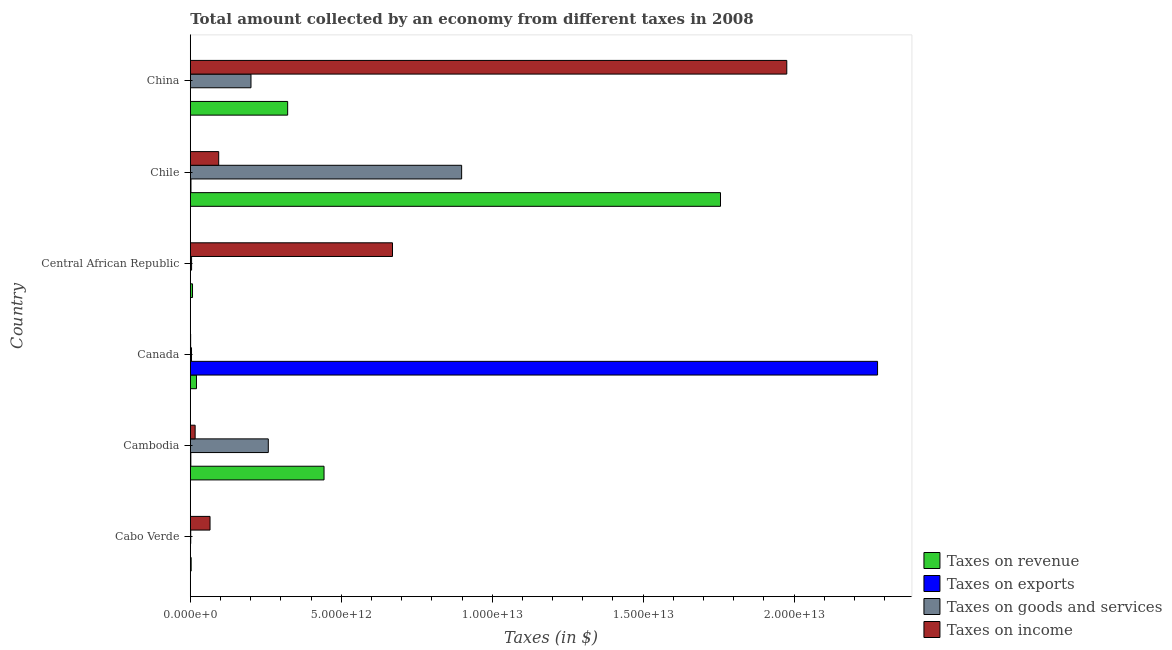How many bars are there on the 2nd tick from the top?
Ensure brevity in your answer.  4. What is the label of the 1st group of bars from the top?
Your response must be concise. China. What is the amount collected as tax on goods in Cambodia?
Your answer should be compact. 2.58e+12. Across all countries, what is the maximum amount collected as tax on income?
Your answer should be compact. 1.98e+13. Across all countries, what is the minimum amount collected as tax on income?
Give a very brief answer. 1.14e+1. In which country was the amount collected as tax on goods minimum?
Provide a succinct answer. Cabo Verde. What is the total amount collected as tax on goods in the graph?
Offer a very short reply. 1.37e+13. What is the difference between the amount collected as tax on exports in Chile and that in China?
Offer a very short reply. 2.21e+1. What is the difference between the amount collected as tax on exports in Central African Republic and the amount collected as tax on revenue in Chile?
Your answer should be very brief. -1.76e+13. What is the average amount collected as tax on income per country?
Your answer should be compact. 4.70e+12. What is the difference between the amount collected as tax on exports and amount collected as tax on revenue in Cambodia?
Ensure brevity in your answer.  -4.41e+12. What is the ratio of the amount collected as tax on exports in Canada to that in Chile?
Your response must be concise. 1022.38. Is the amount collected as tax on goods in Cambodia less than that in Central African Republic?
Your response must be concise. No. What is the difference between the highest and the second highest amount collected as tax on goods?
Give a very brief answer. 6.40e+12. What is the difference between the highest and the lowest amount collected as tax on income?
Make the answer very short. 1.97e+13. Is it the case that in every country, the sum of the amount collected as tax on goods and amount collected as tax on exports is greater than the sum of amount collected as tax on income and amount collected as tax on revenue?
Provide a succinct answer. No. What does the 3rd bar from the top in Chile represents?
Keep it short and to the point. Taxes on exports. What does the 1st bar from the bottom in Cabo Verde represents?
Provide a short and direct response. Taxes on revenue. Is it the case that in every country, the sum of the amount collected as tax on revenue and amount collected as tax on exports is greater than the amount collected as tax on goods?
Your answer should be compact. Yes. How many bars are there?
Offer a very short reply. 24. Are all the bars in the graph horizontal?
Give a very brief answer. Yes. What is the difference between two consecutive major ticks on the X-axis?
Offer a very short reply. 5.00e+12. Are the values on the major ticks of X-axis written in scientific E-notation?
Give a very brief answer. Yes. What is the title of the graph?
Provide a succinct answer. Total amount collected by an economy from different taxes in 2008. Does "International Development Association" appear as one of the legend labels in the graph?
Provide a succinct answer. No. What is the label or title of the X-axis?
Give a very brief answer. Taxes (in $). What is the Taxes (in $) in Taxes on revenue in Cabo Verde?
Your answer should be very brief. 2.87e+1. What is the Taxes (in $) of Taxes on exports in Cabo Verde?
Offer a terse response. 6.26e+06. What is the Taxes (in $) of Taxes on goods and services in Cabo Verde?
Provide a succinct answer. 1.44e+1. What is the Taxes (in $) of Taxes on income in Cabo Verde?
Provide a succinct answer. 6.54e+11. What is the Taxes (in $) in Taxes on revenue in Cambodia?
Provide a short and direct response. 4.43e+12. What is the Taxes (in $) in Taxes on exports in Cambodia?
Give a very brief answer. 1.78e+1. What is the Taxes (in $) of Taxes on goods and services in Cambodia?
Ensure brevity in your answer.  2.58e+12. What is the Taxes (in $) in Taxes on income in Cambodia?
Provide a succinct answer. 1.60e+11. What is the Taxes (in $) of Taxes on revenue in Canada?
Provide a short and direct response. 2.05e+11. What is the Taxes (in $) in Taxes on exports in Canada?
Make the answer very short. 2.28e+13. What is the Taxes (in $) in Taxes on goods and services in Canada?
Offer a very short reply. 4.05e+1. What is the Taxes (in $) in Taxes on income in Canada?
Provide a succinct answer. 1.14e+1. What is the Taxes (in $) of Taxes on revenue in Central African Republic?
Provide a short and direct response. 7.37e+1. What is the Taxes (in $) in Taxes on exports in Central African Republic?
Keep it short and to the point. 1.81e+06. What is the Taxes (in $) of Taxes on goods and services in Central African Republic?
Ensure brevity in your answer.  4.23e+1. What is the Taxes (in $) in Taxes on income in Central African Republic?
Make the answer very short. 6.70e+12. What is the Taxes (in $) in Taxes on revenue in Chile?
Ensure brevity in your answer.  1.76e+13. What is the Taxes (in $) of Taxes on exports in Chile?
Your answer should be very brief. 2.23e+1. What is the Taxes (in $) of Taxes on goods and services in Chile?
Provide a succinct answer. 8.99e+12. What is the Taxes (in $) in Taxes on income in Chile?
Offer a very short reply. 9.41e+11. What is the Taxes (in $) of Taxes on revenue in China?
Give a very brief answer. 3.22e+12. What is the Taxes (in $) in Taxes on exports in China?
Ensure brevity in your answer.  1.39e+08. What is the Taxes (in $) of Taxes on goods and services in China?
Keep it short and to the point. 2.01e+12. What is the Taxes (in $) of Taxes on income in China?
Provide a short and direct response. 1.98e+13. Across all countries, what is the maximum Taxes (in $) of Taxes on revenue?
Your answer should be very brief. 1.76e+13. Across all countries, what is the maximum Taxes (in $) in Taxes on exports?
Provide a short and direct response. 2.28e+13. Across all countries, what is the maximum Taxes (in $) in Taxes on goods and services?
Provide a short and direct response. 8.99e+12. Across all countries, what is the maximum Taxes (in $) of Taxes on income?
Keep it short and to the point. 1.98e+13. Across all countries, what is the minimum Taxes (in $) in Taxes on revenue?
Your response must be concise. 2.87e+1. Across all countries, what is the minimum Taxes (in $) of Taxes on exports?
Offer a very short reply. 1.81e+06. Across all countries, what is the minimum Taxes (in $) of Taxes on goods and services?
Ensure brevity in your answer.  1.44e+1. Across all countries, what is the minimum Taxes (in $) in Taxes on income?
Provide a succinct answer. 1.14e+1. What is the total Taxes (in $) in Taxes on revenue in the graph?
Offer a very short reply. 2.55e+13. What is the total Taxes (in $) in Taxes on exports in the graph?
Ensure brevity in your answer.  2.28e+13. What is the total Taxes (in $) of Taxes on goods and services in the graph?
Give a very brief answer. 1.37e+13. What is the total Taxes (in $) in Taxes on income in the graph?
Provide a short and direct response. 2.82e+13. What is the difference between the Taxes (in $) of Taxes on revenue in Cabo Verde and that in Cambodia?
Keep it short and to the point. -4.40e+12. What is the difference between the Taxes (in $) in Taxes on exports in Cabo Verde and that in Cambodia?
Keep it short and to the point. -1.78e+1. What is the difference between the Taxes (in $) in Taxes on goods and services in Cabo Verde and that in Cambodia?
Offer a very short reply. -2.57e+12. What is the difference between the Taxes (in $) in Taxes on income in Cabo Verde and that in Cambodia?
Your answer should be very brief. 4.93e+11. What is the difference between the Taxes (in $) of Taxes on revenue in Cabo Verde and that in Canada?
Your answer should be compact. -1.76e+11. What is the difference between the Taxes (in $) in Taxes on exports in Cabo Verde and that in Canada?
Your response must be concise. -2.28e+13. What is the difference between the Taxes (in $) of Taxes on goods and services in Cabo Verde and that in Canada?
Give a very brief answer. -2.61e+1. What is the difference between the Taxes (in $) of Taxes on income in Cabo Verde and that in Canada?
Provide a short and direct response. 6.43e+11. What is the difference between the Taxes (in $) in Taxes on revenue in Cabo Verde and that in Central African Republic?
Provide a short and direct response. -4.50e+1. What is the difference between the Taxes (in $) of Taxes on exports in Cabo Verde and that in Central African Republic?
Give a very brief answer. 4.45e+06. What is the difference between the Taxes (in $) of Taxes on goods and services in Cabo Verde and that in Central African Republic?
Keep it short and to the point. -2.79e+1. What is the difference between the Taxes (in $) of Taxes on income in Cabo Verde and that in Central African Republic?
Offer a terse response. -6.04e+12. What is the difference between the Taxes (in $) of Taxes on revenue in Cabo Verde and that in Chile?
Your answer should be compact. -1.75e+13. What is the difference between the Taxes (in $) in Taxes on exports in Cabo Verde and that in Chile?
Ensure brevity in your answer.  -2.23e+1. What is the difference between the Taxes (in $) of Taxes on goods and services in Cabo Verde and that in Chile?
Offer a very short reply. -8.97e+12. What is the difference between the Taxes (in $) of Taxes on income in Cabo Verde and that in Chile?
Provide a succinct answer. -2.87e+11. What is the difference between the Taxes (in $) in Taxes on revenue in Cabo Verde and that in China?
Your response must be concise. -3.20e+12. What is the difference between the Taxes (in $) in Taxes on exports in Cabo Verde and that in China?
Provide a short and direct response. -1.33e+08. What is the difference between the Taxes (in $) of Taxes on goods and services in Cabo Verde and that in China?
Provide a succinct answer. -2.00e+12. What is the difference between the Taxes (in $) of Taxes on income in Cabo Verde and that in China?
Your response must be concise. -1.91e+13. What is the difference between the Taxes (in $) in Taxes on revenue in Cambodia and that in Canada?
Your response must be concise. 4.22e+12. What is the difference between the Taxes (in $) in Taxes on exports in Cambodia and that in Canada?
Ensure brevity in your answer.  -2.27e+13. What is the difference between the Taxes (in $) of Taxes on goods and services in Cambodia and that in Canada?
Your answer should be very brief. 2.54e+12. What is the difference between the Taxes (in $) in Taxes on income in Cambodia and that in Canada?
Keep it short and to the point. 1.49e+11. What is the difference between the Taxes (in $) of Taxes on revenue in Cambodia and that in Central African Republic?
Offer a terse response. 4.36e+12. What is the difference between the Taxes (in $) in Taxes on exports in Cambodia and that in Central African Republic?
Keep it short and to the point. 1.78e+1. What is the difference between the Taxes (in $) in Taxes on goods and services in Cambodia and that in Central African Republic?
Your answer should be very brief. 2.54e+12. What is the difference between the Taxes (in $) of Taxes on income in Cambodia and that in Central African Republic?
Give a very brief answer. -6.54e+12. What is the difference between the Taxes (in $) in Taxes on revenue in Cambodia and that in Chile?
Your answer should be very brief. -1.31e+13. What is the difference between the Taxes (in $) of Taxes on exports in Cambodia and that in Chile?
Offer a very short reply. -4.48e+09. What is the difference between the Taxes (in $) in Taxes on goods and services in Cambodia and that in Chile?
Your answer should be very brief. -6.40e+12. What is the difference between the Taxes (in $) of Taxes on income in Cambodia and that in Chile?
Your answer should be compact. -7.80e+11. What is the difference between the Taxes (in $) in Taxes on revenue in Cambodia and that in China?
Make the answer very short. 1.21e+12. What is the difference between the Taxes (in $) in Taxes on exports in Cambodia and that in China?
Keep it short and to the point. 1.77e+1. What is the difference between the Taxes (in $) of Taxes on goods and services in Cambodia and that in China?
Provide a succinct answer. 5.73e+11. What is the difference between the Taxes (in $) in Taxes on income in Cambodia and that in China?
Offer a very short reply. -1.96e+13. What is the difference between the Taxes (in $) in Taxes on revenue in Canada and that in Central African Republic?
Make the answer very short. 1.31e+11. What is the difference between the Taxes (in $) in Taxes on exports in Canada and that in Central African Republic?
Offer a terse response. 2.28e+13. What is the difference between the Taxes (in $) in Taxes on goods and services in Canada and that in Central African Republic?
Make the answer very short. -1.82e+09. What is the difference between the Taxes (in $) of Taxes on income in Canada and that in Central African Republic?
Provide a short and direct response. -6.69e+12. What is the difference between the Taxes (in $) in Taxes on revenue in Canada and that in Chile?
Give a very brief answer. -1.74e+13. What is the difference between the Taxes (in $) of Taxes on exports in Canada and that in Chile?
Keep it short and to the point. 2.27e+13. What is the difference between the Taxes (in $) in Taxes on goods and services in Canada and that in Chile?
Make the answer very short. -8.95e+12. What is the difference between the Taxes (in $) in Taxes on income in Canada and that in Chile?
Keep it short and to the point. -9.29e+11. What is the difference between the Taxes (in $) of Taxes on revenue in Canada and that in China?
Keep it short and to the point. -3.02e+12. What is the difference between the Taxes (in $) in Taxes on exports in Canada and that in China?
Provide a succinct answer. 2.28e+13. What is the difference between the Taxes (in $) of Taxes on goods and services in Canada and that in China?
Make the answer very short. -1.97e+12. What is the difference between the Taxes (in $) of Taxes on income in Canada and that in China?
Make the answer very short. -1.97e+13. What is the difference between the Taxes (in $) in Taxes on revenue in Central African Republic and that in Chile?
Your answer should be compact. -1.75e+13. What is the difference between the Taxes (in $) of Taxes on exports in Central African Republic and that in Chile?
Give a very brief answer. -2.23e+1. What is the difference between the Taxes (in $) in Taxes on goods and services in Central African Republic and that in Chile?
Offer a terse response. -8.95e+12. What is the difference between the Taxes (in $) of Taxes on income in Central African Republic and that in Chile?
Ensure brevity in your answer.  5.76e+12. What is the difference between the Taxes (in $) in Taxes on revenue in Central African Republic and that in China?
Offer a very short reply. -3.15e+12. What is the difference between the Taxes (in $) in Taxes on exports in Central African Republic and that in China?
Offer a terse response. -1.37e+08. What is the difference between the Taxes (in $) of Taxes on goods and services in Central African Republic and that in China?
Provide a succinct answer. -1.97e+12. What is the difference between the Taxes (in $) in Taxes on income in Central African Republic and that in China?
Your answer should be very brief. -1.31e+13. What is the difference between the Taxes (in $) in Taxes on revenue in Chile and that in China?
Offer a very short reply. 1.43e+13. What is the difference between the Taxes (in $) of Taxes on exports in Chile and that in China?
Provide a short and direct response. 2.21e+1. What is the difference between the Taxes (in $) of Taxes on goods and services in Chile and that in China?
Your response must be concise. 6.98e+12. What is the difference between the Taxes (in $) in Taxes on income in Chile and that in China?
Offer a terse response. -1.88e+13. What is the difference between the Taxes (in $) of Taxes on revenue in Cabo Verde and the Taxes (in $) of Taxes on exports in Cambodia?
Your response must be concise. 1.09e+1. What is the difference between the Taxes (in $) of Taxes on revenue in Cabo Verde and the Taxes (in $) of Taxes on goods and services in Cambodia?
Make the answer very short. -2.55e+12. What is the difference between the Taxes (in $) in Taxes on revenue in Cabo Verde and the Taxes (in $) in Taxes on income in Cambodia?
Ensure brevity in your answer.  -1.32e+11. What is the difference between the Taxes (in $) of Taxes on exports in Cabo Verde and the Taxes (in $) of Taxes on goods and services in Cambodia?
Your answer should be very brief. -2.58e+12. What is the difference between the Taxes (in $) of Taxes on exports in Cabo Verde and the Taxes (in $) of Taxes on income in Cambodia?
Your answer should be compact. -1.60e+11. What is the difference between the Taxes (in $) of Taxes on goods and services in Cabo Verde and the Taxes (in $) of Taxes on income in Cambodia?
Provide a short and direct response. -1.46e+11. What is the difference between the Taxes (in $) of Taxes on revenue in Cabo Verde and the Taxes (in $) of Taxes on exports in Canada?
Provide a succinct answer. -2.27e+13. What is the difference between the Taxes (in $) of Taxes on revenue in Cabo Verde and the Taxes (in $) of Taxes on goods and services in Canada?
Your answer should be compact. -1.18e+1. What is the difference between the Taxes (in $) in Taxes on revenue in Cabo Verde and the Taxes (in $) in Taxes on income in Canada?
Your answer should be very brief. 1.73e+1. What is the difference between the Taxes (in $) of Taxes on exports in Cabo Verde and the Taxes (in $) of Taxes on goods and services in Canada?
Make the answer very short. -4.05e+1. What is the difference between the Taxes (in $) of Taxes on exports in Cabo Verde and the Taxes (in $) of Taxes on income in Canada?
Make the answer very short. -1.14e+1. What is the difference between the Taxes (in $) of Taxes on goods and services in Cabo Verde and the Taxes (in $) of Taxes on income in Canada?
Offer a terse response. 3.04e+09. What is the difference between the Taxes (in $) in Taxes on revenue in Cabo Verde and the Taxes (in $) in Taxes on exports in Central African Republic?
Offer a terse response. 2.87e+1. What is the difference between the Taxes (in $) in Taxes on revenue in Cabo Verde and the Taxes (in $) in Taxes on goods and services in Central African Republic?
Your response must be concise. -1.36e+1. What is the difference between the Taxes (in $) of Taxes on revenue in Cabo Verde and the Taxes (in $) of Taxes on income in Central African Republic?
Your answer should be very brief. -6.67e+12. What is the difference between the Taxes (in $) of Taxes on exports in Cabo Verde and the Taxes (in $) of Taxes on goods and services in Central African Republic?
Keep it short and to the point. -4.23e+1. What is the difference between the Taxes (in $) in Taxes on exports in Cabo Verde and the Taxes (in $) in Taxes on income in Central African Republic?
Ensure brevity in your answer.  -6.70e+12. What is the difference between the Taxes (in $) in Taxes on goods and services in Cabo Verde and the Taxes (in $) in Taxes on income in Central African Republic?
Make the answer very short. -6.68e+12. What is the difference between the Taxes (in $) of Taxes on revenue in Cabo Verde and the Taxes (in $) of Taxes on exports in Chile?
Offer a very short reply. 6.40e+09. What is the difference between the Taxes (in $) in Taxes on revenue in Cabo Verde and the Taxes (in $) in Taxes on goods and services in Chile?
Provide a short and direct response. -8.96e+12. What is the difference between the Taxes (in $) of Taxes on revenue in Cabo Verde and the Taxes (in $) of Taxes on income in Chile?
Make the answer very short. -9.12e+11. What is the difference between the Taxes (in $) in Taxes on exports in Cabo Verde and the Taxes (in $) in Taxes on goods and services in Chile?
Offer a terse response. -8.99e+12. What is the difference between the Taxes (in $) in Taxes on exports in Cabo Verde and the Taxes (in $) in Taxes on income in Chile?
Provide a succinct answer. -9.41e+11. What is the difference between the Taxes (in $) in Taxes on goods and services in Cabo Verde and the Taxes (in $) in Taxes on income in Chile?
Offer a very short reply. -9.26e+11. What is the difference between the Taxes (in $) of Taxes on revenue in Cabo Verde and the Taxes (in $) of Taxes on exports in China?
Offer a very short reply. 2.85e+1. What is the difference between the Taxes (in $) in Taxes on revenue in Cabo Verde and the Taxes (in $) in Taxes on goods and services in China?
Keep it short and to the point. -1.98e+12. What is the difference between the Taxes (in $) in Taxes on revenue in Cabo Verde and the Taxes (in $) in Taxes on income in China?
Give a very brief answer. -1.97e+13. What is the difference between the Taxes (in $) of Taxes on exports in Cabo Verde and the Taxes (in $) of Taxes on goods and services in China?
Your response must be concise. -2.01e+12. What is the difference between the Taxes (in $) in Taxes on exports in Cabo Verde and the Taxes (in $) in Taxes on income in China?
Your answer should be very brief. -1.98e+13. What is the difference between the Taxes (in $) in Taxes on goods and services in Cabo Verde and the Taxes (in $) in Taxes on income in China?
Ensure brevity in your answer.  -1.97e+13. What is the difference between the Taxes (in $) in Taxes on revenue in Cambodia and the Taxes (in $) in Taxes on exports in Canada?
Offer a very short reply. -1.83e+13. What is the difference between the Taxes (in $) of Taxes on revenue in Cambodia and the Taxes (in $) of Taxes on goods and services in Canada?
Make the answer very short. 4.39e+12. What is the difference between the Taxes (in $) in Taxes on revenue in Cambodia and the Taxes (in $) in Taxes on income in Canada?
Make the answer very short. 4.42e+12. What is the difference between the Taxes (in $) in Taxes on exports in Cambodia and the Taxes (in $) in Taxes on goods and services in Canada?
Give a very brief answer. -2.27e+1. What is the difference between the Taxes (in $) of Taxes on exports in Cambodia and the Taxes (in $) of Taxes on income in Canada?
Offer a very short reply. 6.43e+09. What is the difference between the Taxes (in $) of Taxes on goods and services in Cambodia and the Taxes (in $) of Taxes on income in Canada?
Provide a succinct answer. 2.57e+12. What is the difference between the Taxes (in $) of Taxes on revenue in Cambodia and the Taxes (in $) of Taxes on exports in Central African Republic?
Make the answer very short. 4.43e+12. What is the difference between the Taxes (in $) of Taxes on revenue in Cambodia and the Taxes (in $) of Taxes on goods and services in Central African Republic?
Your response must be concise. 4.39e+12. What is the difference between the Taxes (in $) in Taxes on revenue in Cambodia and the Taxes (in $) in Taxes on income in Central African Republic?
Offer a terse response. -2.27e+12. What is the difference between the Taxes (in $) in Taxes on exports in Cambodia and the Taxes (in $) in Taxes on goods and services in Central African Republic?
Ensure brevity in your answer.  -2.45e+1. What is the difference between the Taxes (in $) in Taxes on exports in Cambodia and the Taxes (in $) in Taxes on income in Central African Republic?
Offer a terse response. -6.68e+12. What is the difference between the Taxes (in $) in Taxes on goods and services in Cambodia and the Taxes (in $) in Taxes on income in Central African Republic?
Give a very brief answer. -4.11e+12. What is the difference between the Taxes (in $) of Taxes on revenue in Cambodia and the Taxes (in $) of Taxes on exports in Chile?
Offer a terse response. 4.41e+12. What is the difference between the Taxes (in $) of Taxes on revenue in Cambodia and the Taxes (in $) of Taxes on goods and services in Chile?
Your answer should be compact. -4.56e+12. What is the difference between the Taxes (in $) in Taxes on revenue in Cambodia and the Taxes (in $) in Taxes on income in Chile?
Your response must be concise. 3.49e+12. What is the difference between the Taxes (in $) of Taxes on exports in Cambodia and the Taxes (in $) of Taxes on goods and services in Chile?
Give a very brief answer. -8.97e+12. What is the difference between the Taxes (in $) in Taxes on exports in Cambodia and the Taxes (in $) in Taxes on income in Chile?
Your response must be concise. -9.23e+11. What is the difference between the Taxes (in $) in Taxes on goods and services in Cambodia and the Taxes (in $) in Taxes on income in Chile?
Provide a succinct answer. 1.64e+12. What is the difference between the Taxes (in $) of Taxes on revenue in Cambodia and the Taxes (in $) of Taxes on exports in China?
Make the answer very short. 4.43e+12. What is the difference between the Taxes (in $) in Taxes on revenue in Cambodia and the Taxes (in $) in Taxes on goods and services in China?
Keep it short and to the point. 2.42e+12. What is the difference between the Taxes (in $) of Taxes on revenue in Cambodia and the Taxes (in $) of Taxes on income in China?
Offer a terse response. -1.53e+13. What is the difference between the Taxes (in $) in Taxes on exports in Cambodia and the Taxes (in $) in Taxes on goods and services in China?
Your answer should be compact. -1.99e+12. What is the difference between the Taxes (in $) in Taxes on exports in Cambodia and the Taxes (in $) in Taxes on income in China?
Provide a short and direct response. -1.97e+13. What is the difference between the Taxes (in $) in Taxes on goods and services in Cambodia and the Taxes (in $) in Taxes on income in China?
Give a very brief answer. -1.72e+13. What is the difference between the Taxes (in $) of Taxes on revenue in Canada and the Taxes (in $) of Taxes on exports in Central African Republic?
Offer a very short reply. 2.05e+11. What is the difference between the Taxes (in $) of Taxes on revenue in Canada and the Taxes (in $) of Taxes on goods and services in Central African Republic?
Provide a short and direct response. 1.63e+11. What is the difference between the Taxes (in $) of Taxes on revenue in Canada and the Taxes (in $) of Taxes on income in Central African Republic?
Give a very brief answer. -6.49e+12. What is the difference between the Taxes (in $) of Taxes on exports in Canada and the Taxes (in $) of Taxes on goods and services in Central African Republic?
Make the answer very short. 2.27e+13. What is the difference between the Taxes (in $) of Taxes on exports in Canada and the Taxes (in $) of Taxes on income in Central African Republic?
Your response must be concise. 1.61e+13. What is the difference between the Taxes (in $) in Taxes on goods and services in Canada and the Taxes (in $) in Taxes on income in Central African Republic?
Offer a very short reply. -6.66e+12. What is the difference between the Taxes (in $) of Taxes on revenue in Canada and the Taxes (in $) of Taxes on exports in Chile?
Provide a succinct answer. 1.83e+11. What is the difference between the Taxes (in $) in Taxes on revenue in Canada and the Taxes (in $) in Taxes on goods and services in Chile?
Your answer should be compact. -8.78e+12. What is the difference between the Taxes (in $) in Taxes on revenue in Canada and the Taxes (in $) in Taxes on income in Chile?
Offer a very short reply. -7.36e+11. What is the difference between the Taxes (in $) of Taxes on exports in Canada and the Taxes (in $) of Taxes on goods and services in Chile?
Give a very brief answer. 1.38e+13. What is the difference between the Taxes (in $) of Taxes on exports in Canada and the Taxes (in $) of Taxes on income in Chile?
Provide a short and direct response. 2.18e+13. What is the difference between the Taxes (in $) of Taxes on goods and services in Canada and the Taxes (in $) of Taxes on income in Chile?
Keep it short and to the point. -9.00e+11. What is the difference between the Taxes (in $) of Taxes on revenue in Canada and the Taxes (in $) of Taxes on exports in China?
Your answer should be very brief. 2.05e+11. What is the difference between the Taxes (in $) of Taxes on revenue in Canada and the Taxes (in $) of Taxes on goods and services in China?
Your response must be concise. -1.81e+12. What is the difference between the Taxes (in $) of Taxes on revenue in Canada and the Taxes (in $) of Taxes on income in China?
Ensure brevity in your answer.  -1.96e+13. What is the difference between the Taxes (in $) in Taxes on exports in Canada and the Taxes (in $) in Taxes on goods and services in China?
Give a very brief answer. 2.08e+13. What is the difference between the Taxes (in $) in Taxes on exports in Canada and the Taxes (in $) in Taxes on income in China?
Provide a succinct answer. 3.01e+12. What is the difference between the Taxes (in $) of Taxes on goods and services in Canada and the Taxes (in $) of Taxes on income in China?
Ensure brevity in your answer.  -1.97e+13. What is the difference between the Taxes (in $) in Taxes on revenue in Central African Republic and the Taxes (in $) in Taxes on exports in Chile?
Make the answer very short. 5.14e+1. What is the difference between the Taxes (in $) in Taxes on revenue in Central African Republic and the Taxes (in $) in Taxes on goods and services in Chile?
Keep it short and to the point. -8.91e+12. What is the difference between the Taxes (in $) in Taxes on revenue in Central African Republic and the Taxes (in $) in Taxes on income in Chile?
Ensure brevity in your answer.  -8.67e+11. What is the difference between the Taxes (in $) of Taxes on exports in Central African Republic and the Taxes (in $) of Taxes on goods and services in Chile?
Your answer should be compact. -8.99e+12. What is the difference between the Taxes (in $) in Taxes on exports in Central African Republic and the Taxes (in $) in Taxes on income in Chile?
Make the answer very short. -9.41e+11. What is the difference between the Taxes (in $) in Taxes on goods and services in Central African Republic and the Taxes (in $) in Taxes on income in Chile?
Provide a succinct answer. -8.98e+11. What is the difference between the Taxes (in $) of Taxes on revenue in Central African Republic and the Taxes (in $) of Taxes on exports in China?
Ensure brevity in your answer.  7.35e+1. What is the difference between the Taxes (in $) of Taxes on revenue in Central African Republic and the Taxes (in $) of Taxes on goods and services in China?
Ensure brevity in your answer.  -1.94e+12. What is the difference between the Taxes (in $) of Taxes on revenue in Central African Republic and the Taxes (in $) of Taxes on income in China?
Offer a very short reply. -1.97e+13. What is the difference between the Taxes (in $) of Taxes on exports in Central African Republic and the Taxes (in $) of Taxes on goods and services in China?
Provide a succinct answer. -2.01e+12. What is the difference between the Taxes (in $) in Taxes on exports in Central African Republic and the Taxes (in $) in Taxes on income in China?
Offer a very short reply. -1.98e+13. What is the difference between the Taxes (in $) in Taxes on goods and services in Central African Republic and the Taxes (in $) in Taxes on income in China?
Your answer should be compact. -1.97e+13. What is the difference between the Taxes (in $) of Taxes on revenue in Chile and the Taxes (in $) of Taxes on exports in China?
Offer a very short reply. 1.76e+13. What is the difference between the Taxes (in $) in Taxes on revenue in Chile and the Taxes (in $) in Taxes on goods and services in China?
Keep it short and to the point. 1.56e+13. What is the difference between the Taxes (in $) of Taxes on revenue in Chile and the Taxes (in $) of Taxes on income in China?
Provide a short and direct response. -2.20e+12. What is the difference between the Taxes (in $) of Taxes on exports in Chile and the Taxes (in $) of Taxes on goods and services in China?
Your answer should be very brief. -1.99e+12. What is the difference between the Taxes (in $) of Taxes on exports in Chile and the Taxes (in $) of Taxes on income in China?
Keep it short and to the point. -1.97e+13. What is the difference between the Taxes (in $) in Taxes on goods and services in Chile and the Taxes (in $) in Taxes on income in China?
Offer a very short reply. -1.08e+13. What is the average Taxes (in $) of Taxes on revenue per country?
Keep it short and to the point. 4.25e+12. What is the average Taxes (in $) of Taxes on exports per country?
Provide a succinct answer. 3.80e+12. What is the average Taxes (in $) in Taxes on goods and services per country?
Offer a very short reply. 2.28e+12. What is the average Taxes (in $) in Taxes on income per country?
Your answer should be very brief. 4.70e+12. What is the difference between the Taxes (in $) in Taxes on revenue and Taxes (in $) in Taxes on exports in Cabo Verde?
Offer a very short reply. 2.87e+1. What is the difference between the Taxes (in $) in Taxes on revenue and Taxes (in $) in Taxes on goods and services in Cabo Verde?
Offer a very short reply. 1.43e+1. What is the difference between the Taxes (in $) in Taxes on revenue and Taxes (in $) in Taxes on income in Cabo Verde?
Ensure brevity in your answer.  -6.25e+11. What is the difference between the Taxes (in $) of Taxes on exports and Taxes (in $) of Taxes on goods and services in Cabo Verde?
Keep it short and to the point. -1.44e+1. What is the difference between the Taxes (in $) of Taxes on exports and Taxes (in $) of Taxes on income in Cabo Verde?
Offer a terse response. -6.54e+11. What is the difference between the Taxes (in $) of Taxes on goods and services and Taxes (in $) of Taxes on income in Cabo Verde?
Keep it short and to the point. -6.39e+11. What is the difference between the Taxes (in $) of Taxes on revenue and Taxes (in $) of Taxes on exports in Cambodia?
Make the answer very short. 4.41e+12. What is the difference between the Taxes (in $) of Taxes on revenue and Taxes (in $) of Taxes on goods and services in Cambodia?
Your answer should be very brief. 1.85e+12. What is the difference between the Taxes (in $) of Taxes on revenue and Taxes (in $) of Taxes on income in Cambodia?
Your answer should be compact. 4.27e+12. What is the difference between the Taxes (in $) in Taxes on exports and Taxes (in $) in Taxes on goods and services in Cambodia?
Give a very brief answer. -2.57e+12. What is the difference between the Taxes (in $) in Taxes on exports and Taxes (in $) in Taxes on income in Cambodia?
Make the answer very short. -1.43e+11. What is the difference between the Taxes (in $) in Taxes on goods and services and Taxes (in $) in Taxes on income in Cambodia?
Provide a short and direct response. 2.42e+12. What is the difference between the Taxes (in $) in Taxes on revenue and Taxes (in $) in Taxes on exports in Canada?
Your answer should be very brief. -2.26e+13. What is the difference between the Taxes (in $) in Taxes on revenue and Taxes (in $) in Taxes on goods and services in Canada?
Keep it short and to the point. 1.64e+11. What is the difference between the Taxes (in $) in Taxes on revenue and Taxes (in $) in Taxes on income in Canada?
Provide a succinct answer. 1.93e+11. What is the difference between the Taxes (in $) of Taxes on exports and Taxes (in $) of Taxes on goods and services in Canada?
Your answer should be very brief. 2.27e+13. What is the difference between the Taxes (in $) of Taxes on exports and Taxes (in $) of Taxes on income in Canada?
Your answer should be compact. 2.28e+13. What is the difference between the Taxes (in $) of Taxes on goods and services and Taxes (in $) of Taxes on income in Canada?
Your response must be concise. 2.91e+1. What is the difference between the Taxes (in $) in Taxes on revenue and Taxes (in $) in Taxes on exports in Central African Republic?
Provide a succinct answer. 7.37e+1. What is the difference between the Taxes (in $) in Taxes on revenue and Taxes (in $) in Taxes on goods and services in Central African Republic?
Ensure brevity in your answer.  3.14e+1. What is the difference between the Taxes (in $) of Taxes on revenue and Taxes (in $) of Taxes on income in Central African Republic?
Your answer should be very brief. -6.62e+12. What is the difference between the Taxes (in $) of Taxes on exports and Taxes (in $) of Taxes on goods and services in Central African Republic?
Provide a succinct answer. -4.23e+1. What is the difference between the Taxes (in $) in Taxes on exports and Taxes (in $) in Taxes on income in Central African Republic?
Your answer should be compact. -6.70e+12. What is the difference between the Taxes (in $) of Taxes on goods and services and Taxes (in $) of Taxes on income in Central African Republic?
Your response must be concise. -6.66e+12. What is the difference between the Taxes (in $) of Taxes on revenue and Taxes (in $) of Taxes on exports in Chile?
Ensure brevity in your answer.  1.75e+13. What is the difference between the Taxes (in $) in Taxes on revenue and Taxes (in $) in Taxes on goods and services in Chile?
Offer a terse response. 8.57e+12. What is the difference between the Taxes (in $) of Taxes on revenue and Taxes (in $) of Taxes on income in Chile?
Offer a very short reply. 1.66e+13. What is the difference between the Taxes (in $) in Taxes on exports and Taxes (in $) in Taxes on goods and services in Chile?
Make the answer very short. -8.97e+12. What is the difference between the Taxes (in $) in Taxes on exports and Taxes (in $) in Taxes on income in Chile?
Your answer should be compact. -9.19e+11. What is the difference between the Taxes (in $) in Taxes on goods and services and Taxes (in $) in Taxes on income in Chile?
Your answer should be very brief. 8.05e+12. What is the difference between the Taxes (in $) of Taxes on revenue and Taxes (in $) of Taxes on exports in China?
Ensure brevity in your answer.  3.22e+12. What is the difference between the Taxes (in $) in Taxes on revenue and Taxes (in $) in Taxes on goods and services in China?
Provide a short and direct response. 1.21e+12. What is the difference between the Taxes (in $) in Taxes on revenue and Taxes (in $) in Taxes on income in China?
Provide a short and direct response. -1.65e+13. What is the difference between the Taxes (in $) of Taxes on exports and Taxes (in $) of Taxes on goods and services in China?
Offer a terse response. -2.01e+12. What is the difference between the Taxes (in $) of Taxes on exports and Taxes (in $) of Taxes on income in China?
Your answer should be compact. -1.98e+13. What is the difference between the Taxes (in $) in Taxes on goods and services and Taxes (in $) in Taxes on income in China?
Provide a short and direct response. -1.77e+13. What is the ratio of the Taxes (in $) of Taxes on revenue in Cabo Verde to that in Cambodia?
Your answer should be very brief. 0.01. What is the ratio of the Taxes (in $) in Taxes on goods and services in Cabo Verde to that in Cambodia?
Make the answer very short. 0.01. What is the ratio of the Taxes (in $) of Taxes on income in Cabo Verde to that in Cambodia?
Offer a terse response. 4.08. What is the ratio of the Taxes (in $) of Taxes on revenue in Cabo Verde to that in Canada?
Give a very brief answer. 0.14. What is the ratio of the Taxes (in $) of Taxes on exports in Cabo Verde to that in Canada?
Your answer should be compact. 0. What is the ratio of the Taxes (in $) in Taxes on goods and services in Cabo Verde to that in Canada?
Give a very brief answer. 0.36. What is the ratio of the Taxes (in $) in Taxes on income in Cabo Verde to that in Canada?
Offer a very short reply. 57.55. What is the ratio of the Taxes (in $) of Taxes on revenue in Cabo Verde to that in Central African Republic?
Your response must be concise. 0.39. What is the ratio of the Taxes (in $) of Taxes on exports in Cabo Verde to that in Central African Republic?
Make the answer very short. 3.46. What is the ratio of the Taxes (in $) of Taxes on goods and services in Cabo Verde to that in Central African Republic?
Ensure brevity in your answer.  0.34. What is the ratio of the Taxes (in $) in Taxes on income in Cabo Verde to that in Central African Republic?
Offer a very short reply. 0.1. What is the ratio of the Taxes (in $) in Taxes on revenue in Cabo Verde to that in Chile?
Ensure brevity in your answer.  0. What is the ratio of the Taxes (in $) in Taxes on goods and services in Cabo Verde to that in Chile?
Ensure brevity in your answer.  0. What is the ratio of the Taxes (in $) in Taxes on income in Cabo Verde to that in Chile?
Give a very brief answer. 0.69. What is the ratio of the Taxes (in $) in Taxes on revenue in Cabo Verde to that in China?
Your response must be concise. 0.01. What is the ratio of the Taxes (in $) in Taxes on exports in Cabo Verde to that in China?
Ensure brevity in your answer.  0.04. What is the ratio of the Taxes (in $) in Taxes on goods and services in Cabo Verde to that in China?
Keep it short and to the point. 0.01. What is the ratio of the Taxes (in $) of Taxes on income in Cabo Verde to that in China?
Provide a short and direct response. 0.03. What is the ratio of the Taxes (in $) of Taxes on revenue in Cambodia to that in Canada?
Give a very brief answer. 21.62. What is the ratio of the Taxes (in $) in Taxes on exports in Cambodia to that in Canada?
Make the answer very short. 0. What is the ratio of the Taxes (in $) of Taxes on goods and services in Cambodia to that in Canada?
Offer a terse response. 63.85. What is the ratio of the Taxes (in $) in Taxes on income in Cambodia to that in Canada?
Give a very brief answer. 14.12. What is the ratio of the Taxes (in $) in Taxes on revenue in Cambodia to that in Central African Republic?
Offer a terse response. 60.14. What is the ratio of the Taxes (in $) in Taxes on exports in Cambodia to that in Central African Republic?
Ensure brevity in your answer.  9839.6. What is the ratio of the Taxes (in $) of Taxes on goods and services in Cambodia to that in Central African Republic?
Provide a succinct answer. 61.1. What is the ratio of the Taxes (in $) in Taxes on income in Cambodia to that in Central African Republic?
Offer a very short reply. 0.02. What is the ratio of the Taxes (in $) of Taxes on revenue in Cambodia to that in Chile?
Provide a succinct answer. 0.25. What is the ratio of the Taxes (in $) in Taxes on exports in Cambodia to that in Chile?
Ensure brevity in your answer.  0.8. What is the ratio of the Taxes (in $) of Taxes on goods and services in Cambodia to that in Chile?
Make the answer very short. 0.29. What is the ratio of the Taxes (in $) of Taxes on income in Cambodia to that in Chile?
Provide a short and direct response. 0.17. What is the ratio of the Taxes (in $) of Taxes on revenue in Cambodia to that in China?
Provide a short and direct response. 1.37. What is the ratio of the Taxes (in $) in Taxes on exports in Cambodia to that in China?
Your answer should be compact. 127.8. What is the ratio of the Taxes (in $) in Taxes on goods and services in Cambodia to that in China?
Your answer should be very brief. 1.29. What is the ratio of the Taxes (in $) of Taxes on income in Cambodia to that in China?
Your response must be concise. 0.01. What is the ratio of the Taxes (in $) in Taxes on revenue in Canada to that in Central African Republic?
Keep it short and to the point. 2.78. What is the ratio of the Taxes (in $) of Taxes on exports in Canada to that in Central African Republic?
Provide a succinct answer. 1.26e+07. What is the ratio of the Taxes (in $) of Taxes on goods and services in Canada to that in Central African Republic?
Give a very brief answer. 0.96. What is the ratio of the Taxes (in $) of Taxes on income in Canada to that in Central African Republic?
Your response must be concise. 0. What is the ratio of the Taxes (in $) in Taxes on revenue in Canada to that in Chile?
Make the answer very short. 0.01. What is the ratio of the Taxes (in $) of Taxes on exports in Canada to that in Chile?
Provide a short and direct response. 1022.39. What is the ratio of the Taxes (in $) in Taxes on goods and services in Canada to that in Chile?
Give a very brief answer. 0. What is the ratio of the Taxes (in $) in Taxes on income in Canada to that in Chile?
Make the answer very short. 0.01. What is the ratio of the Taxes (in $) in Taxes on revenue in Canada to that in China?
Your answer should be compact. 0.06. What is the ratio of the Taxes (in $) of Taxes on exports in Canada to that in China?
Keep it short and to the point. 1.64e+05. What is the ratio of the Taxes (in $) in Taxes on goods and services in Canada to that in China?
Offer a very short reply. 0.02. What is the ratio of the Taxes (in $) of Taxes on income in Canada to that in China?
Give a very brief answer. 0. What is the ratio of the Taxes (in $) of Taxes on revenue in Central African Republic to that in Chile?
Provide a succinct answer. 0. What is the ratio of the Taxes (in $) in Taxes on exports in Central African Republic to that in Chile?
Make the answer very short. 0. What is the ratio of the Taxes (in $) in Taxes on goods and services in Central African Republic to that in Chile?
Provide a short and direct response. 0. What is the ratio of the Taxes (in $) of Taxes on income in Central African Republic to that in Chile?
Provide a succinct answer. 7.12. What is the ratio of the Taxes (in $) of Taxes on revenue in Central African Republic to that in China?
Provide a succinct answer. 0.02. What is the ratio of the Taxes (in $) in Taxes on exports in Central African Republic to that in China?
Make the answer very short. 0.01. What is the ratio of the Taxes (in $) of Taxes on goods and services in Central African Republic to that in China?
Give a very brief answer. 0.02. What is the ratio of the Taxes (in $) of Taxes on income in Central African Republic to that in China?
Keep it short and to the point. 0.34. What is the ratio of the Taxes (in $) of Taxes on revenue in Chile to that in China?
Make the answer very short. 5.45. What is the ratio of the Taxes (in $) in Taxes on exports in Chile to that in China?
Keep it short and to the point. 159.96. What is the ratio of the Taxes (in $) of Taxes on goods and services in Chile to that in China?
Offer a very short reply. 4.47. What is the ratio of the Taxes (in $) of Taxes on income in Chile to that in China?
Provide a short and direct response. 0.05. What is the difference between the highest and the second highest Taxes (in $) in Taxes on revenue?
Make the answer very short. 1.31e+13. What is the difference between the highest and the second highest Taxes (in $) in Taxes on exports?
Offer a terse response. 2.27e+13. What is the difference between the highest and the second highest Taxes (in $) of Taxes on goods and services?
Give a very brief answer. 6.40e+12. What is the difference between the highest and the second highest Taxes (in $) in Taxes on income?
Your answer should be compact. 1.31e+13. What is the difference between the highest and the lowest Taxes (in $) of Taxes on revenue?
Your answer should be very brief. 1.75e+13. What is the difference between the highest and the lowest Taxes (in $) of Taxes on exports?
Your response must be concise. 2.28e+13. What is the difference between the highest and the lowest Taxes (in $) in Taxes on goods and services?
Provide a succinct answer. 8.97e+12. What is the difference between the highest and the lowest Taxes (in $) in Taxes on income?
Offer a terse response. 1.97e+13. 